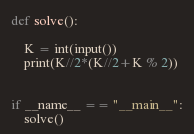<code> <loc_0><loc_0><loc_500><loc_500><_Python_>def solve():

    K = int(input())
    print(K//2*(K//2+K % 2))


if __name__ == "__main__":
    solve()
</code> 